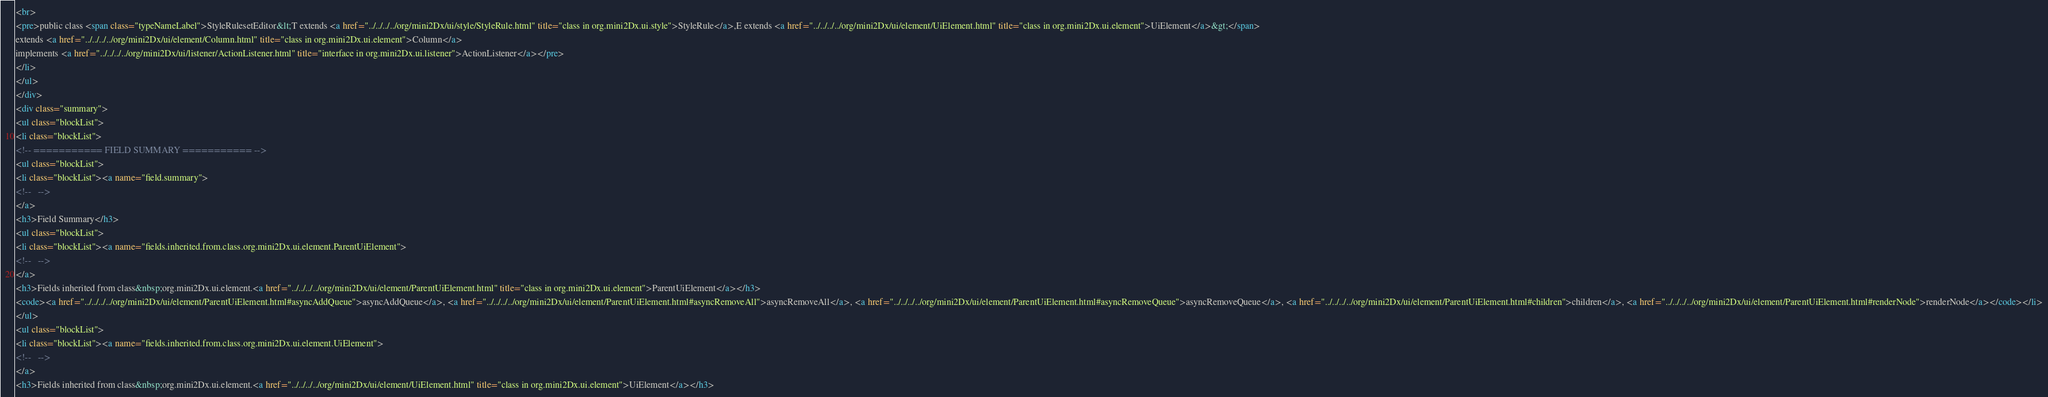<code> <loc_0><loc_0><loc_500><loc_500><_HTML_><br>
<pre>public class <span class="typeNameLabel">StyleRulesetEditor&lt;T extends <a href="../../../../org/mini2Dx/ui/style/StyleRule.html" title="class in org.mini2Dx.ui.style">StyleRule</a>,E extends <a href="../../../../org/mini2Dx/ui/element/UiElement.html" title="class in org.mini2Dx.ui.element">UiElement</a>&gt;</span>
extends <a href="../../../../org/mini2Dx/ui/element/Column.html" title="class in org.mini2Dx.ui.element">Column</a>
implements <a href="../../../../org/mini2Dx/ui/listener/ActionListener.html" title="interface in org.mini2Dx.ui.listener">ActionListener</a></pre>
</li>
</ul>
</div>
<div class="summary">
<ul class="blockList">
<li class="blockList">
<!-- =========== FIELD SUMMARY =========== -->
<ul class="blockList">
<li class="blockList"><a name="field.summary">
<!--   -->
</a>
<h3>Field Summary</h3>
<ul class="blockList">
<li class="blockList"><a name="fields.inherited.from.class.org.mini2Dx.ui.element.ParentUiElement">
<!--   -->
</a>
<h3>Fields inherited from class&nbsp;org.mini2Dx.ui.element.<a href="../../../../org/mini2Dx/ui/element/ParentUiElement.html" title="class in org.mini2Dx.ui.element">ParentUiElement</a></h3>
<code><a href="../../../../org/mini2Dx/ui/element/ParentUiElement.html#asyncAddQueue">asyncAddQueue</a>, <a href="../../../../org/mini2Dx/ui/element/ParentUiElement.html#asyncRemoveAll">asyncRemoveAll</a>, <a href="../../../../org/mini2Dx/ui/element/ParentUiElement.html#asyncRemoveQueue">asyncRemoveQueue</a>, <a href="../../../../org/mini2Dx/ui/element/ParentUiElement.html#children">children</a>, <a href="../../../../org/mini2Dx/ui/element/ParentUiElement.html#renderNode">renderNode</a></code></li>
</ul>
<ul class="blockList">
<li class="blockList"><a name="fields.inherited.from.class.org.mini2Dx.ui.element.UiElement">
<!--   -->
</a>
<h3>Fields inherited from class&nbsp;org.mini2Dx.ui.element.<a href="../../../../org/mini2Dx/ui/element/UiElement.html" title="class in org.mini2Dx.ui.element">UiElement</a></h3></code> 